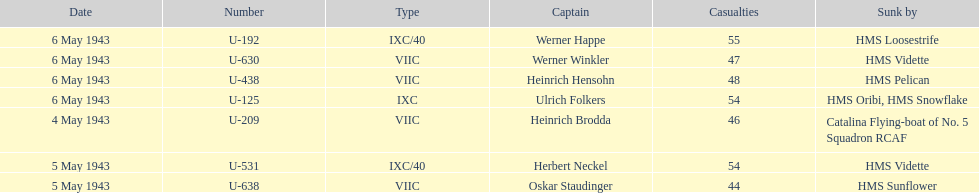Could you parse the entire table as a dict? {'header': ['Date', 'Number', 'Type', 'Captain', 'Casualties', 'Sunk by'], 'rows': [['6 May 1943', 'U-192', 'IXC/40', 'Werner Happe', '55', 'HMS Loosestrife'], ['6 May 1943', 'U-630', 'VIIC', 'Werner Winkler', '47', 'HMS Vidette'], ['6 May 1943', 'U-438', 'VIIC', 'Heinrich Hensohn', '48', 'HMS Pelican'], ['6 May 1943', 'U-125', 'IXC', 'Ulrich Folkers', '54', 'HMS Oribi, HMS Snowflake'], ['4 May 1943', 'U-209', 'VIIC', 'Heinrich Brodda', '46', 'Catalina Flying-boat of No. 5 Squadron RCAF'], ['5 May 1943', 'U-531', 'IXC/40', 'Herbert Neckel', '54', 'HMS Vidette'], ['5 May 1943', 'U-638', 'VIIC', 'Oskar Staudinger', '44', 'HMS Sunflower']]} Which ship sunk the most u-boats HMS Vidette. 